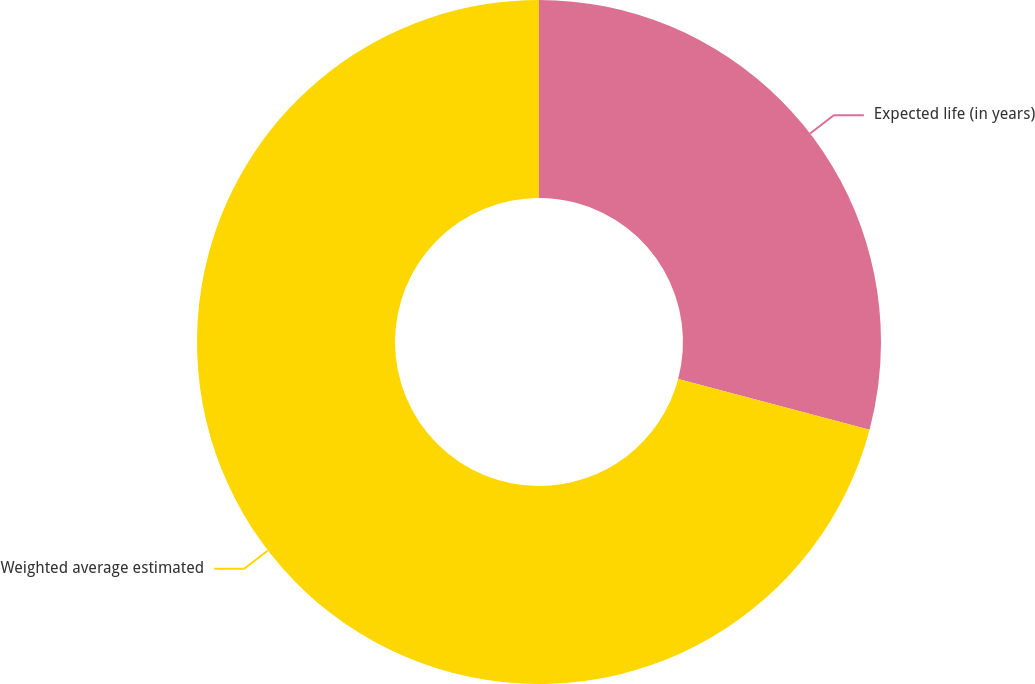<chart> <loc_0><loc_0><loc_500><loc_500><pie_chart><fcel>Expected life (in years)<fcel>Weighted average estimated<nl><fcel>29.13%<fcel>70.87%<nl></chart> 